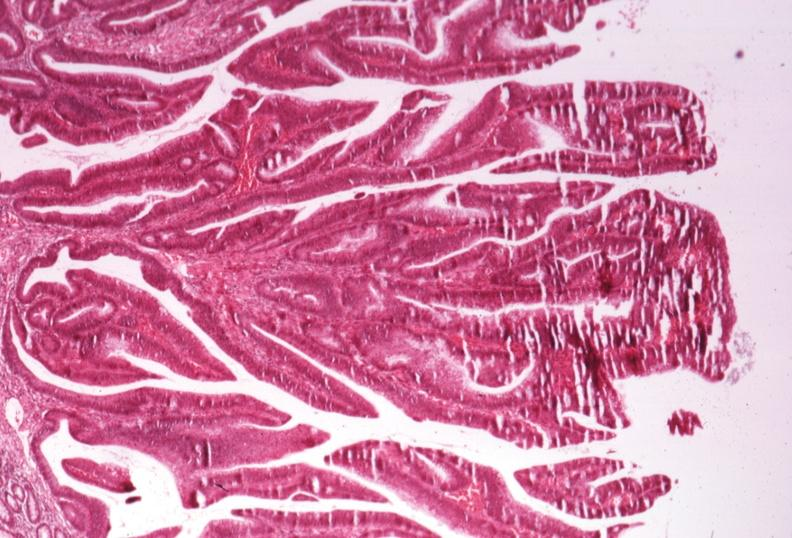what is present?
Answer the question using a single word or phrase. Colon 